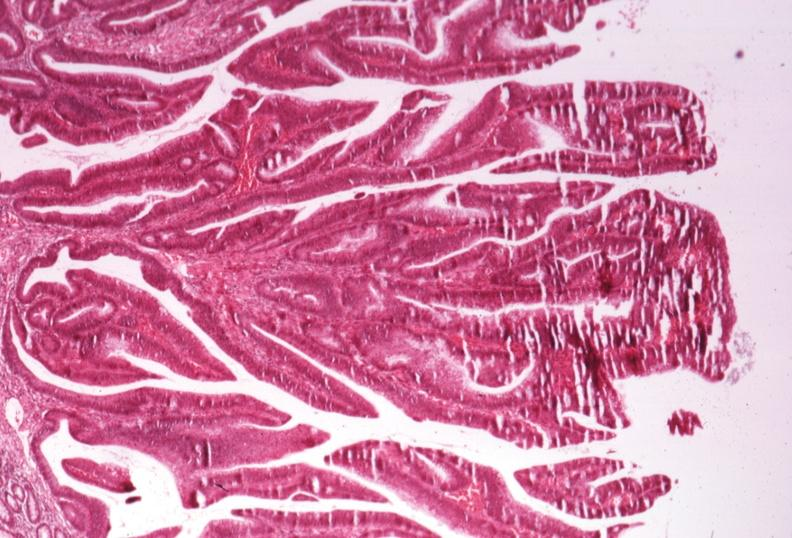what is present?
Answer the question using a single word or phrase. Colon 